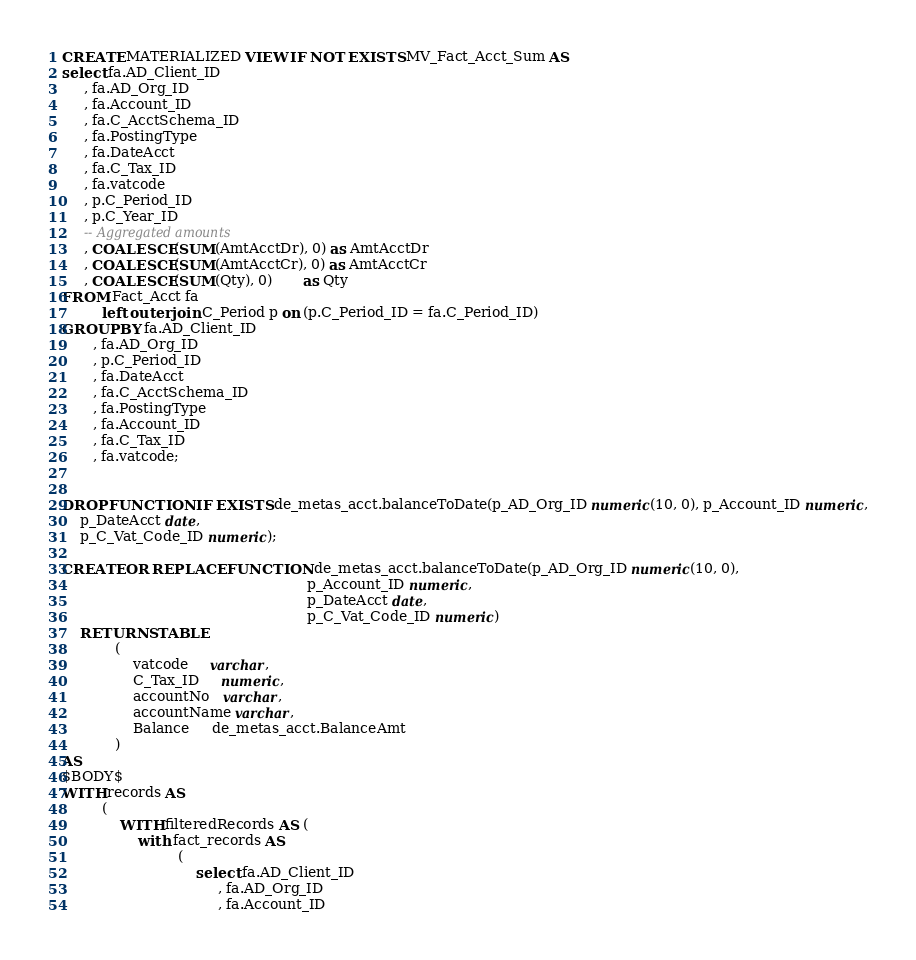Convert code to text. <code><loc_0><loc_0><loc_500><loc_500><_SQL_>CREATE MATERIALIZED VIEW IF NOT EXISTS MV_Fact_Acct_Sum AS
select fa.AD_Client_ID
     , fa.AD_Org_ID
     , fa.Account_ID
     , fa.C_AcctSchema_ID
     , fa.PostingType
     , fa.DateAcct
     , fa.C_Tax_ID
     , fa.vatcode
     , p.C_Period_ID
     , p.C_Year_ID
     -- Aggregated amounts
     , COALESCE(SUM(AmtAcctDr), 0) as AmtAcctDr
     , COALESCE(SUM(AmtAcctCr), 0) as AmtAcctCr
     , COALESCE(SUM(Qty), 0)       as Qty
FROM Fact_Acct fa
         left outer join C_Period p on (p.C_Period_ID = fa.C_Period_ID)
GROUP BY fa.AD_Client_ID
       , fa.AD_Org_ID
       , p.C_Period_ID
       , fa.DateAcct
       , fa.C_AcctSchema_ID
       , fa.PostingType
       , fa.Account_ID
       , fa.C_Tax_ID
       , fa.vatcode;
	   
	   
DROP FUNCTION IF EXISTS de_metas_acct.balanceToDate(p_AD_Org_ID numeric(10, 0), p_Account_ID numeric,
    p_DateAcct date,
    p_C_Vat_Code_ID numeric);

CREATE OR REPLACE FUNCTION de_metas_acct.balanceToDate(p_AD_Org_ID numeric(10, 0),
                                                       p_Account_ID numeric,
                                                       p_DateAcct date,
                                                       p_C_Vat_Code_ID numeric)
    RETURNS TABLE
            (
                vatcode     varchar,
                C_Tax_ID     numeric,
				accountNo   varchar,
				accountName varchar,
                Balance     de_metas_acct.BalanceAmt
            )
AS
$BODY$
WITH records AS
         (
             WITH filteredRecords AS (
                 with fact_records AS
                          (
                              select fa.AD_Client_ID
                                   , fa.AD_Org_ID
                                   , fa.Account_ID</code> 